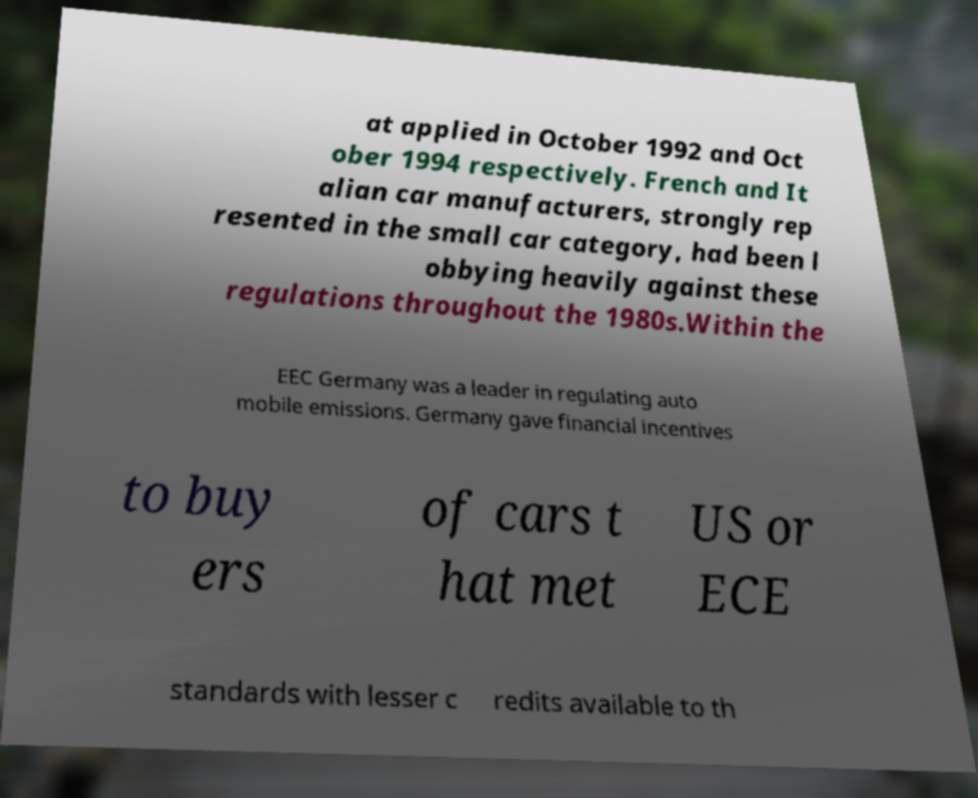Could you extract and type out the text from this image? at applied in October 1992 and Oct ober 1994 respectively. French and It alian car manufacturers, strongly rep resented in the small car category, had been l obbying heavily against these regulations throughout the 1980s.Within the EEC Germany was a leader in regulating auto mobile emissions. Germany gave financial incentives to buy ers of cars t hat met US or ECE standards with lesser c redits available to th 